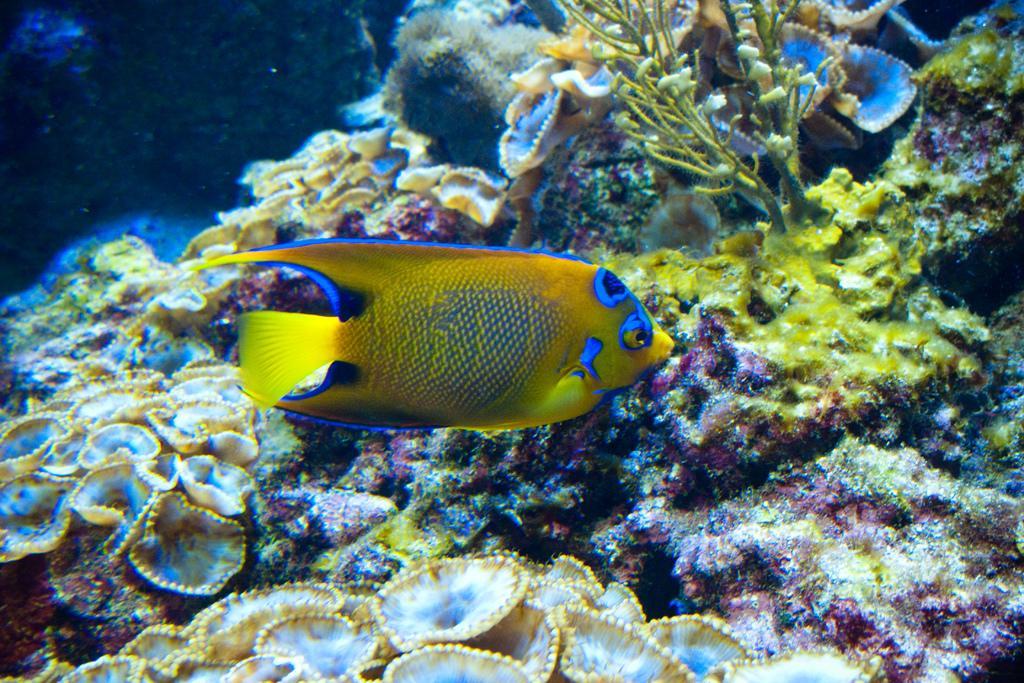Could you give a brief overview of what you see in this image? In this image I can see the underwater picture in which I can see few aquatic plants and a fish which is yellow, blue and black in color. 